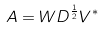<formula> <loc_0><loc_0><loc_500><loc_500>A = W D ^ { \frac { 1 } { 2 } } V ^ { * }</formula> 